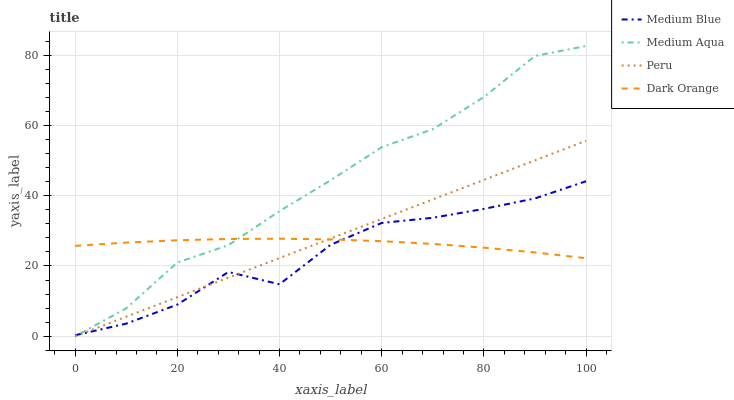Does Peru have the minimum area under the curve?
Answer yes or no. No. Does Peru have the maximum area under the curve?
Answer yes or no. No. Is Medium Blue the smoothest?
Answer yes or no. No. Is Peru the roughest?
Answer yes or no. No. Does Medium Blue have the lowest value?
Answer yes or no. No. Does Medium Blue have the highest value?
Answer yes or no. No. 